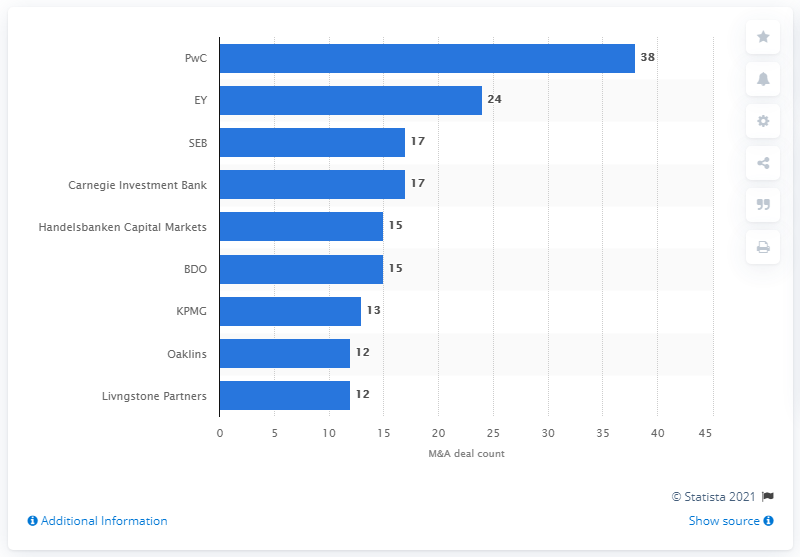Identify some key points in this picture. In 2016, PriceWaterhouseCoopers had a total of 38 deals. 